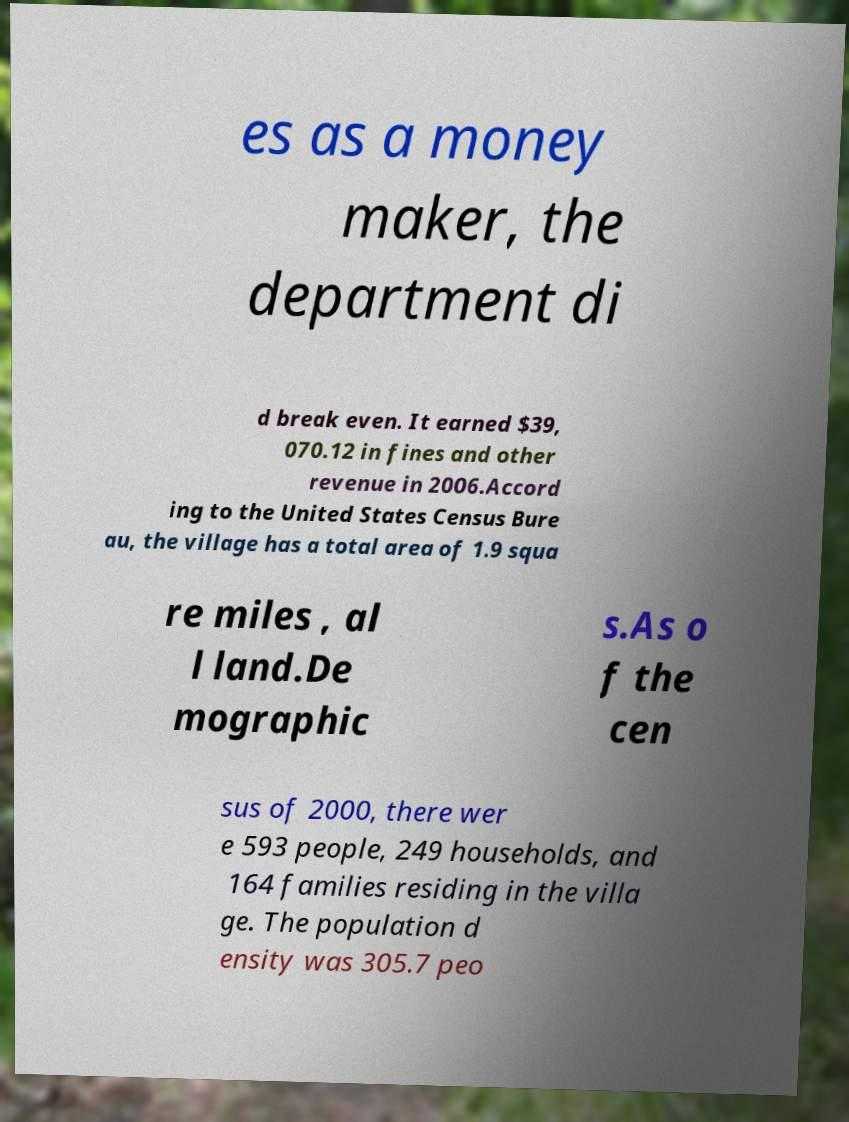Please read and relay the text visible in this image. What does it say? es as a money maker, the department di d break even. It earned $39, 070.12 in fines and other revenue in 2006.Accord ing to the United States Census Bure au, the village has a total area of 1.9 squa re miles , al l land.De mographic s.As o f the cen sus of 2000, there wer e 593 people, 249 households, and 164 families residing in the villa ge. The population d ensity was 305.7 peo 